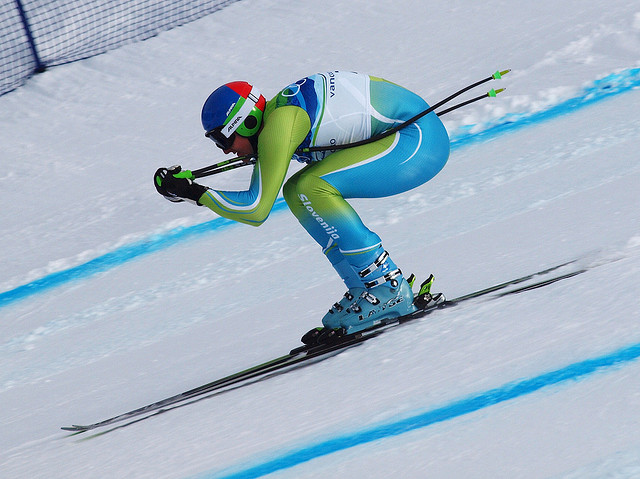Identify the text contained in this image. Slivenija 